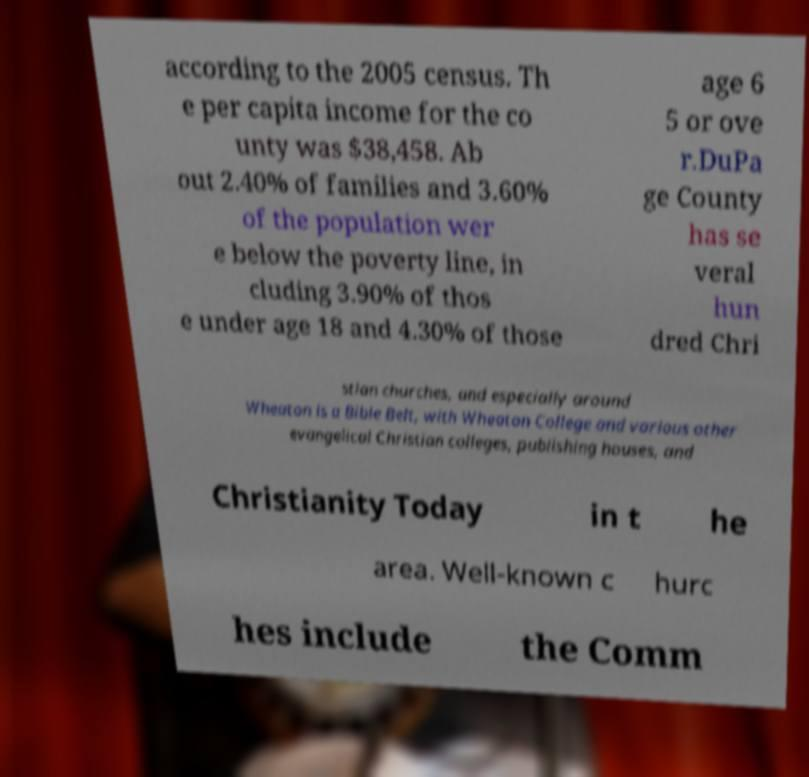Can you read and provide the text displayed in the image?This photo seems to have some interesting text. Can you extract and type it out for me? according to the 2005 census. Th e per capita income for the co unty was $38,458. Ab out 2.40% of families and 3.60% of the population wer e below the poverty line, in cluding 3.90% of thos e under age 18 and 4.30% of those age 6 5 or ove r.DuPa ge County has se veral hun dred Chri stian churches, and especially around Wheaton is a Bible Belt, with Wheaton College and various other evangelical Christian colleges, publishing houses, and Christianity Today in t he area. Well-known c hurc hes include the Comm 